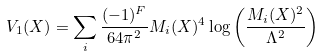<formula> <loc_0><loc_0><loc_500><loc_500>V _ { 1 } ( X ) = \sum _ { i } \frac { ( - 1 ) ^ { F } } { 6 4 \pi ^ { 2 } } M _ { i } ( X ) ^ { 4 } \log \left ( \frac { M _ { i } ( X ) ^ { 2 } } { \Lambda ^ { 2 } } \right )</formula> 